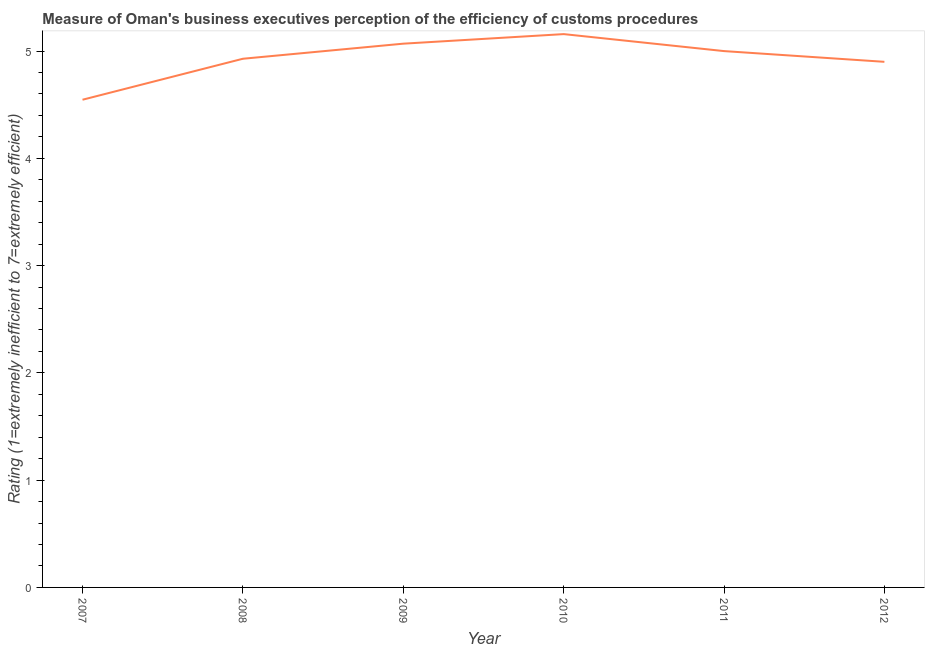Across all years, what is the maximum rating measuring burden of customs procedure?
Your answer should be very brief. 5.16. Across all years, what is the minimum rating measuring burden of customs procedure?
Offer a very short reply. 4.55. What is the sum of the rating measuring burden of customs procedure?
Offer a terse response. 29.6. What is the difference between the rating measuring burden of customs procedure in 2008 and 2011?
Ensure brevity in your answer.  -0.07. What is the average rating measuring burden of customs procedure per year?
Your answer should be very brief. 4.93. What is the median rating measuring burden of customs procedure?
Give a very brief answer. 4.96. Do a majority of the years between 2009 and 2008 (inclusive) have rating measuring burden of customs procedure greater than 1.8 ?
Offer a very short reply. No. What is the ratio of the rating measuring burden of customs procedure in 2007 to that in 2009?
Make the answer very short. 0.9. What is the difference between the highest and the second highest rating measuring burden of customs procedure?
Your answer should be compact. 0.09. Is the sum of the rating measuring burden of customs procedure in 2008 and 2009 greater than the maximum rating measuring burden of customs procedure across all years?
Offer a terse response. Yes. What is the difference between the highest and the lowest rating measuring burden of customs procedure?
Your answer should be compact. 0.61. In how many years, is the rating measuring burden of customs procedure greater than the average rating measuring burden of customs procedure taken over all years?
Provide a succinct answer. 3. What is the difference between two consecutive major ticks on the Y-axis?
Provide a succinct answer. 1. Are the values on the major ticks of Y-axis written in scientific E-notation?
Keep it short and to the point. No. What is the title of the graph?
Provide a short and direct response. Measure of Oman's business executives perception of the efficiency of customs procedures. What is the label or title of the X-axis?
Make the answer very short. Year. What is the label or title of the Y-axis?
Your response must be concise. Rating (1=extremely inefficient to 7=extremely efficient). What is the Rating (1=extremely inefficient to 7=extremely efficient) in 2007?
Keep it short and to the point. 4.55. What is the Rating (1=extremely inefficient to 7=extremely efficient) of 2008?
Keep it short and to the point. 4.93. What is the Rating (1=extremely inefficient to 7=extremely efficient) in 2009?
Make the answer very short. 5.07. What is the Rating (1=extremely inefficient to 7=extremely efficient) of 2010?
Make the answer very short. 5.16. What is the Rating (1=extremely inefficient to 7=extremely efficient) of 2012?
Provide a short and direct response. 4.9. What is the difference between the Rating (1=extremely inefficient to 7=extremely efficient) in 2007 and 2008?
Offer a very short reply. -0.38. What is the difference between the Rating (1=extremely inefficient to 7=extremely efficient) in 2007 and 2009?
Offer a very short reply. -0.52. What is the difference between the Rating (1=extremely inefficient to 7=extremely efficient) in 2007 and 2010?
Provide a succinct answer. -0.61. What is the difference between the Rating (1=extremely inefficient to 7=extremely efficient) in 2007 and 2011?
Your answer should be compact. -0.45. What is the difference between the Rating (1=extremely inefficient to 7=extremely efficient) in 2007 and 2012?
Ensure brevity in your answer.  -0.35. What is the difference between the Rating (1=extremely inefficient to 7=extremely efficient) in 2008 and 2009?
Your response must be concise. -0.14. What is the difference between the Rating (1=extremely inefficient to 7=extremely efficient) in 2008 and 2010?
Offer a very short reply. -0.23. What is the difference between the Rating (1=extremely inefficient to 7=extremely efficient) in 2008 and 2011?
Your answer should be compact. -0.07. What is the difference between the Rating (1=extremely inefficient to 7=extremely efficient) in 2008 and 2012?
Give a very brief answer. 0.03. What is the difference between the Rating (1=extremely inefficient to 7=extremely efficient) in 2009 and 2010?
Your answer should be compact. -0.09. What is the difference between the Rating (1=extremely inefficient to 7=extremely efficient) in 2009 and 2011?
Offer a very short reply. 0.07. What is the difference between the Rating (1=extremely inefficient to 7=extremely efficient) in 2009 and 2012?
Ensure brevity in your answer.  0.17. What is the difference between the Rating (1=extremely inefficient to 7=extremely efficient) in 2010 and 2011?
Provide a succinct answer. 0.16. What is the difference between the Rating (1=extremely inefficient to 7=extremely efficient) in 2010 and 2012?
Ensure brevity in your answer.  0.26. What is the difference between the Rating (1=extremely inefficient to 7=extremely efficient) in 2011 and 2012?
Give a very brief answer. 0.1. What is the ratio of the Rating (1=extremely inefficient to 7=extremely efficient) in 2007 to that in 2008?
Give a very brief answer. 0.92. What is the ratio of the Rating (1=extremely inefficient to 7=extremely efficient) in 2007 to that in 2009?
Offer a very short reply. 0.9. What is the ratio of the Rating (1=extremely inefficient to 7=extremely efficient) in 2007 to that in 2010?
Offer a terse response. 0.88. What is the ratio of the Rating (1=extremely inefficient to 7=extremely efficient) in 2007 to that in 2011?
Your response must be concise. 0.91. What is the ratio of the Rating (1=extremely inefficient to 7=extremely efficient) in 2007 to that in 2012?
Offer a terse response. 0.93. What is the ratio of the Rating (1=extremely inefficient to 7=extremely efficient) in 2008 to that in 2009?
Ensure brevity in your answer.  0.97. What is the ratio of the Rating (1=extremely inefficient to 7=extremely efficient) in 2008 to that in 2010?
Offer a very short reply. 0.95. What is the ratio of the Rating (1=extremely inefficient to 7=extremely efficient) in 2008 to that in 2011?
Provide a short and direct response. 0.99. What is the ratio of the Rating (1=extremely inefficient to 7=extremely efficient) in 2008 to that in 2012?
Provide a short and direct response. 1.01. What is the ratio of the Rating (1=extremely inefficient to 7=extremely efficient) in 2009 to that in 2010?
Ensure brevity in your answer.  0.98. What is the ratio of the Rating (1=extremely inefficient to 7=extremely efficient) in 2009 to that in 2011?
Give a very brief answer. 1.01. What is the ratio of the Rating (1=extremely inefficient to 7=extremely efficient) in 2009 to that in 2012?
Provide a succinct answer. 1.03. What is the ratio of the Rating (1=extremely inefficient to 7=extremely efficient) in 2010 to that in 2011?
Give a very brief answer. 1.03. What is the ratio of the Rating (1=extremely inefficient to 7=extremely efficient) in 2010 to that in 2012?
Offer a terse response. 1.05. 